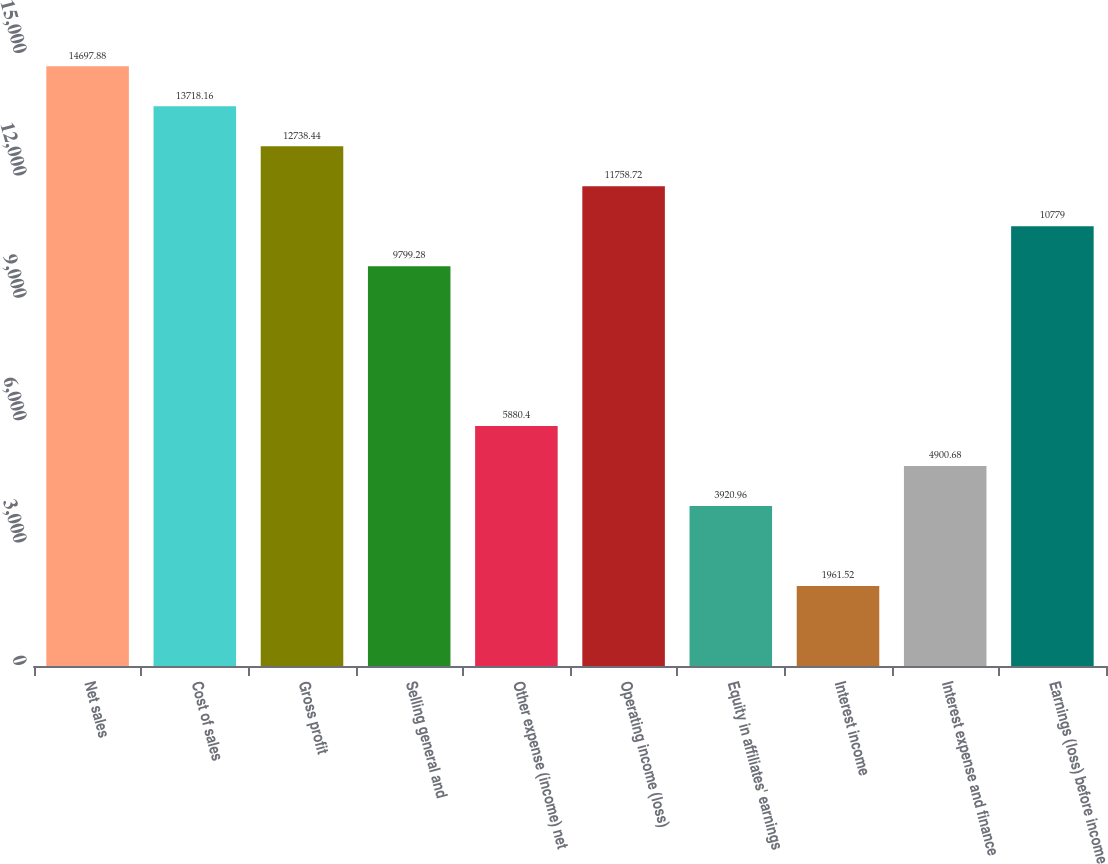<chart> <loc_0><loc_0><loc_500><loc_500><bar_chart><fcel>Net sales<fcel>Cost of sales<fcel>Gross profit<fcel>Selling general and<fcel>Other expense (income) net<fcel>Operating income (loss)<fcel>Equity in affiliates' earnings<fcel>Interest income<fcel>Interest expense and finance<fcel>Earnings (loss) before income<nl><fcel>14697.9<fcel>13718.2<fcel>12738.4<fcel>9799.28<fcel>5880.4<fcel>11758.7<fcel>3920.96<fcel>1961.52<fcel>4900.68<fcel>10779<nl></chart> 